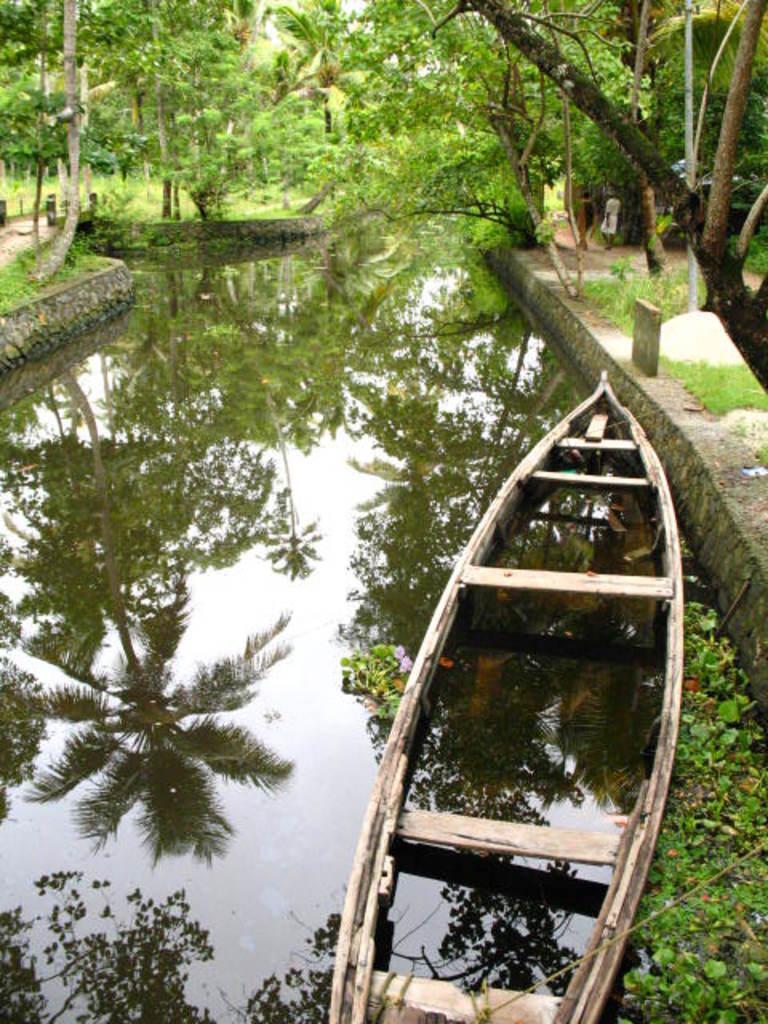Can you describe this image briefly? In this image we can see the wooden canoe in the water and it is on the right side. Here we can see the water. Here we can see a person on the right side. Here we can see the trees on the left side and the right side as well. 